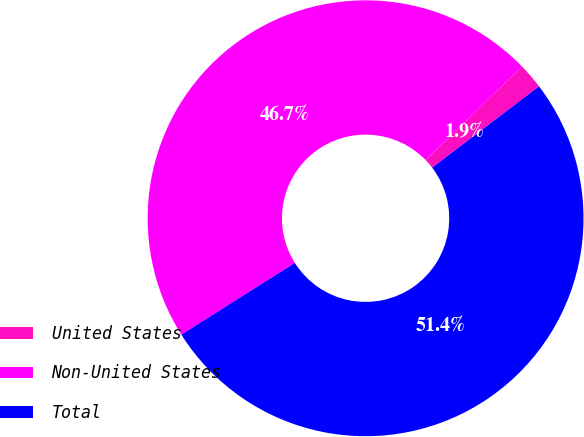Convert chart. <chart><loc_0><loc_0><loc_500><loc_500><pie_chart><fcel>United States<fcel>Non-United States<fcel>Total<nl><fcel>1.91%<fcel>46.71%<fcel>51.38%<nl></chart> 